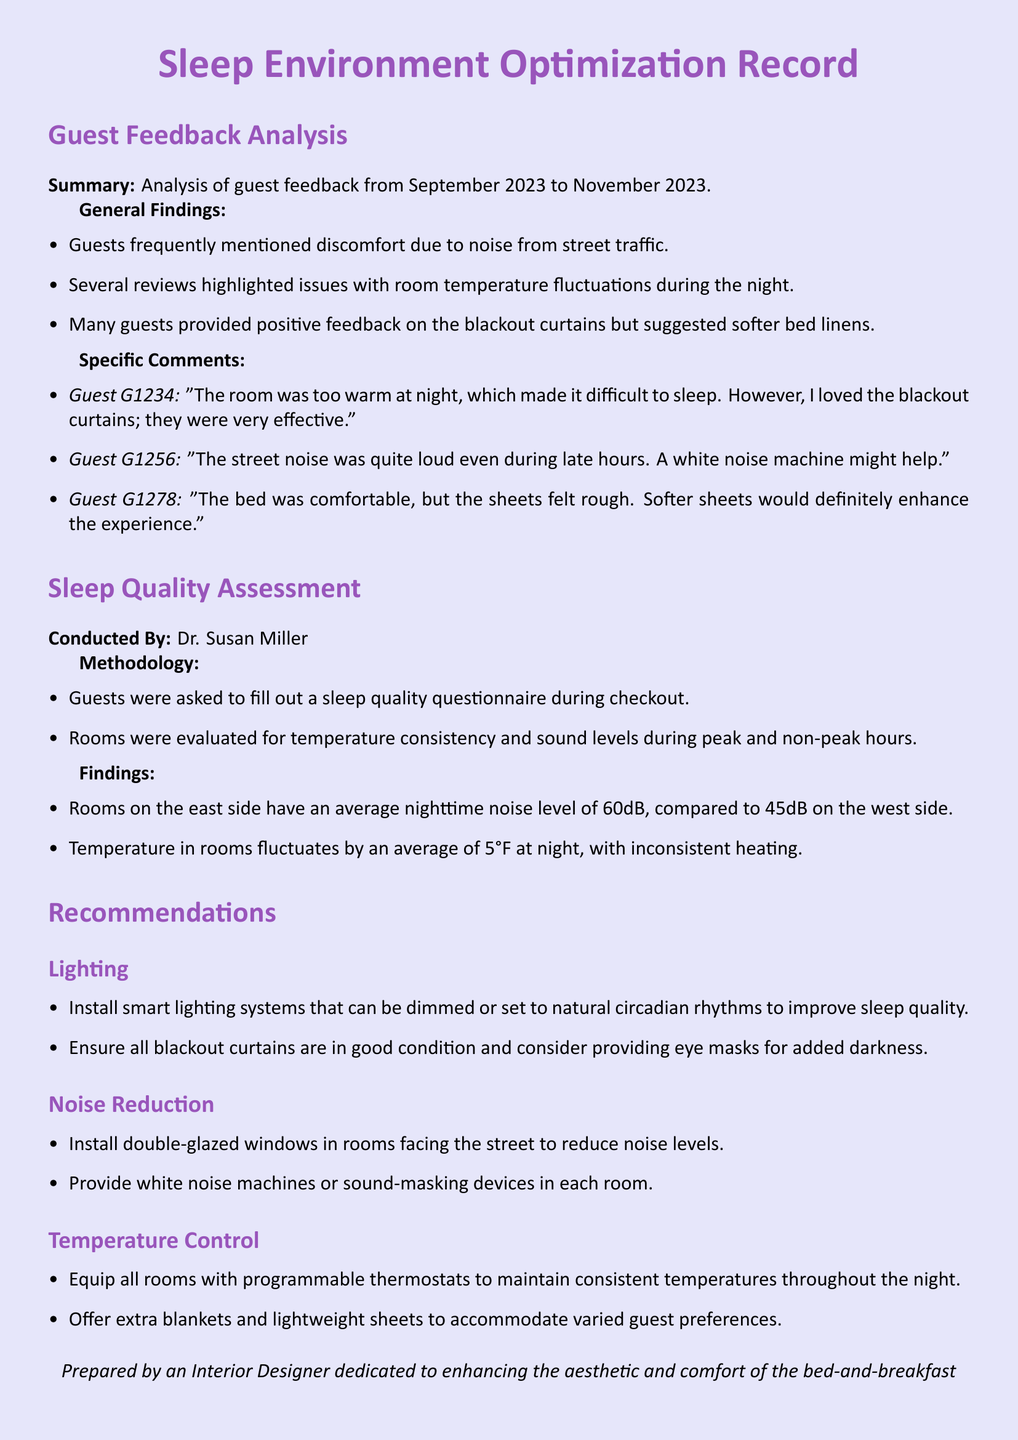what was the average nighttime noise level in rooms on the east side? The document states that rooms on the east side have an average nighttime noise level of 60dB.
Answer: 60dB who conducted the sleep quality assessment? The document mentions that the sleep quality assessment was conducted by Dr. Susan Miller.
Answer: Dr. Susan Miller what were guests' comments on bed linens? The specific comments indicated that many guests felt the sheets were rough and suggested that softer sheets would enhance the experience.
Answer: Softer sheets what should be installed to reduce noise levels in street-facing rooms? The recommendations include installing double-glazed windows in rooms facing the street to reduce noise levels.
Answer: Double-glazed windows how much does the temperature fluctuate in rooms at night? The text mentions that the temperature in rooms fluctuates by an average of 5°F at night, indicating consistency issues.
Answer: 5°F what lighting improvement is recommended in the document? The recommendations suggest installing smart lighting systems that can be dimmed or set to natural circadian rhythms.
Answer: Smart lighting systems what kind of feedback was frequently mentioned by guests? Guests frequently mentioned discomfort due to noise from street traffic in their feedback.
Answer: Noise from street traffic what features are suggested to maintain consistent room temperature? The document recommends equipping all rooms with programmable thermostats to maintain consistent temperatures at night.
Answer: Programmable thermostats 